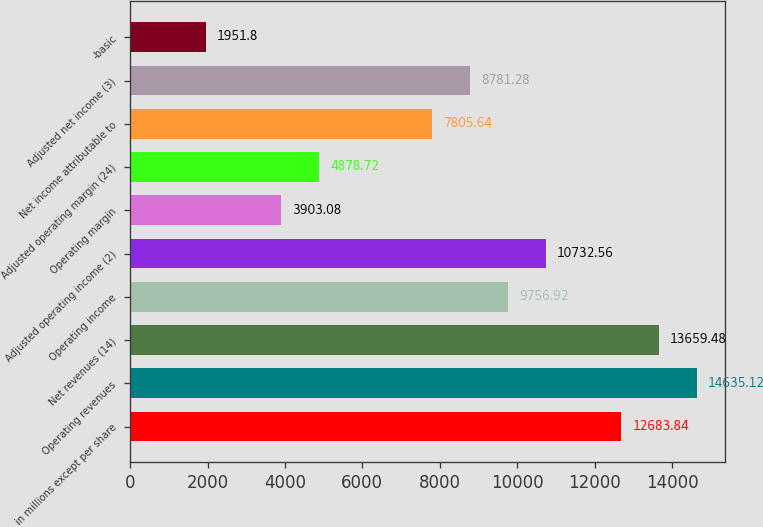Convert chart to OTSL. <chart><loc_0><loc_0><loc_500><loc_500><bar_chart><fcel>in millions except per share<fcel>Operating revenues<fcel>Net revenues (14)<fcel>Operating income<fcel>Adjusted operating income (2)<fcel>Operating margin<fcel>Adjusted operating margin (24)<fcel>Net income attributable to<fcel>Adjusted net income (3)<fcel>-basic<nl><fcel>12683.8<fcel>14635.1<fcel>13659.5<fcel>9756.92<fcel>10732.6<fcel>3903.08<fcel>4878.72<fcel>7805.64<fcel>8781.28<fcel>1951.8<nl></chart> 